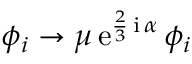<formula> <loc_0><loc_0><loc_500><loc_500>\phi _ { i } \rightarrow \mu \, e ^ { \frac { 2 } { 3 } \, i \, \alpha } \, \phi _ { i }</formula> 